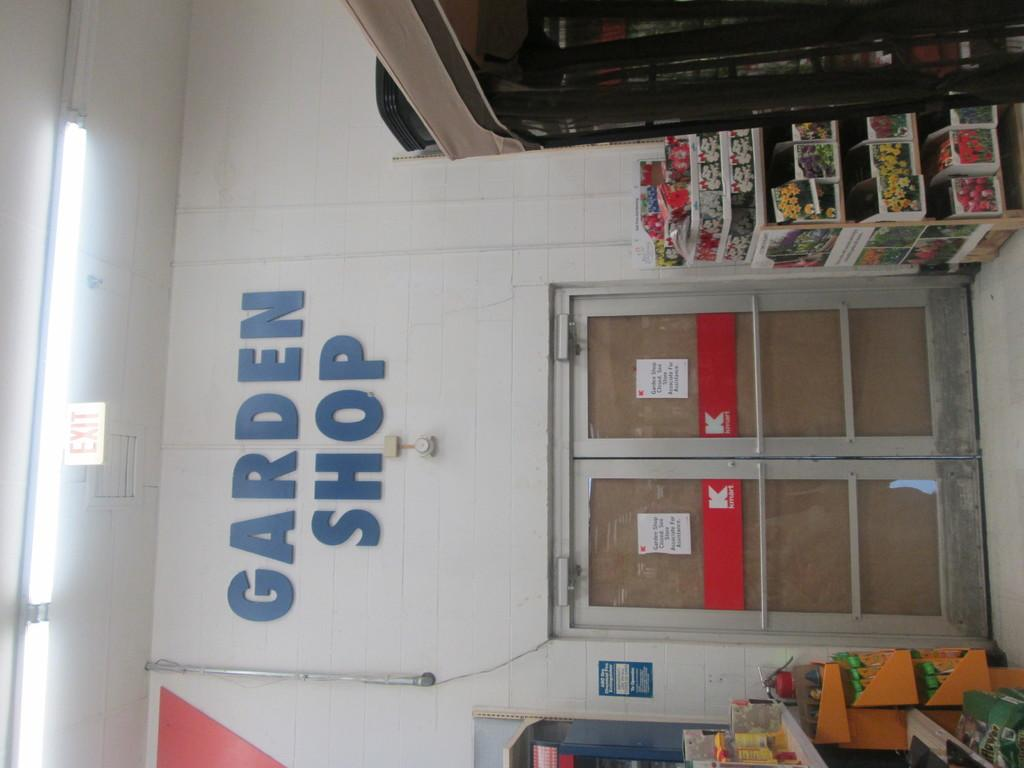<image>
Provide a brief description of the given image. The doors of a kmart are located in the garden shop. 